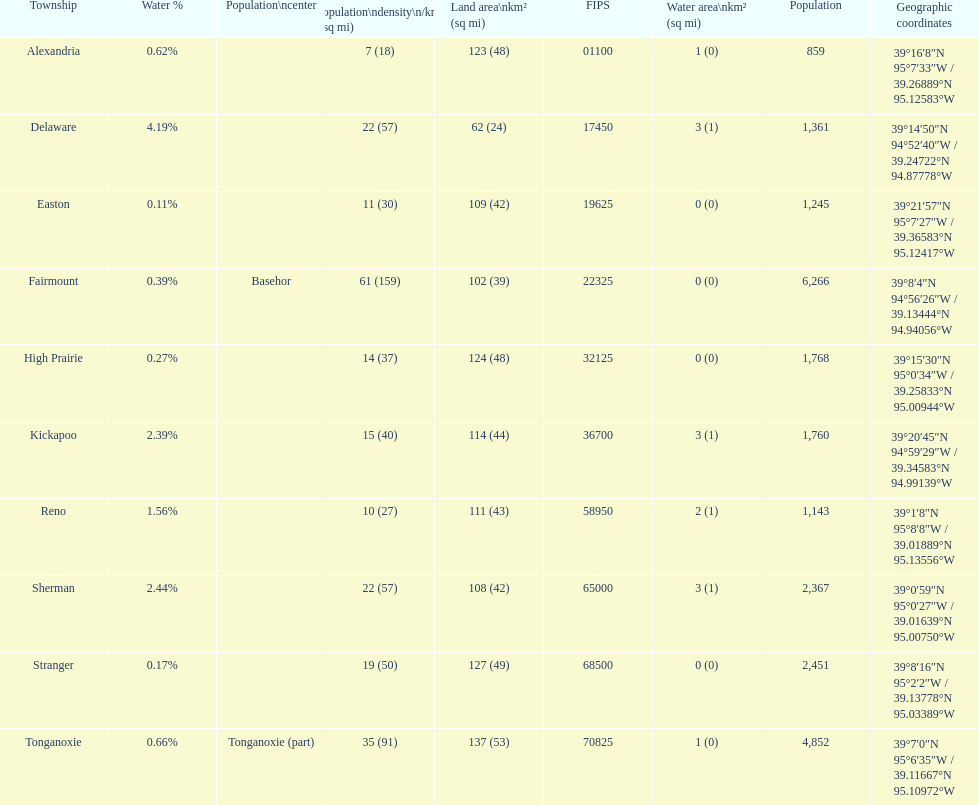Does alexandria county have a higher or lower population than delaware county? Lower. 